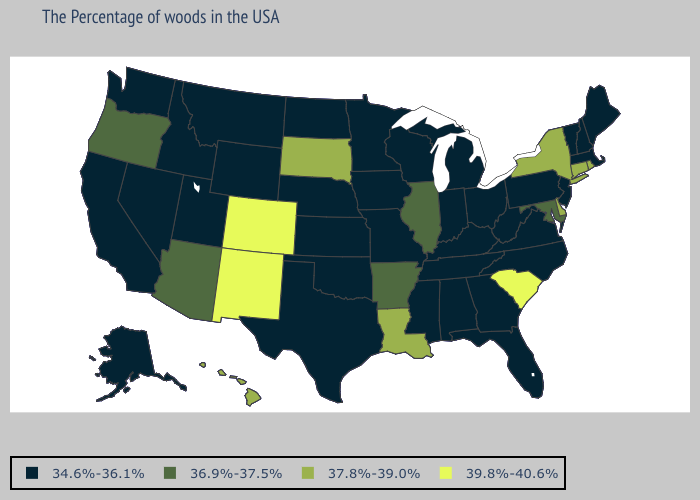Does Texas have a lower value than Delaware?
Write a very short answer. Yes. What is the lowest value in the Northeast?
Answer briefly. 34.6%-36.1%. What is the lowest value in states that border Illinois?
Concise answer only. 34.6%-36.1%. Which states have the lowest value in the USA?
Give a very brief answer. Maine, Massachusetts, New Hampshire, Vermont, New Jersey, Pennsylvania, Virginia, North Carolina, West Virginia, Ohio, Florida, Georgia, Michigan, Kentucky, Indiana, Alabama, Tennessee, Wisconsin, Mississippi, Missouri, Minnesota, Iowa, Kansas, Nebraska, Oklahoma, Texas, North Dakota, Wyoming, Utah, Montana, Idaho, Nevada, California, Washington, Alaska. What is the value of Texas?
Quick response, please. 34.6%-36.1%. What is the highest value in states that border Wyoming?
Give a very brief answer. 39.8%-40.6%. Name the states that have a value in the range 39.8%-40.6%?
Concise answer only. South Carolina, Colorado, New Mexico. What is the lowest value in the USA?
Concise answer only. 34.6%-36.1%. Does the map have missing data?
Short answer required. No. How many symbols are there in the legend?
Concise answer only. 4. Among the states that border Alabama , which have the lowest value?
Keep it brief. Florida, Georgia, Tennessee, Mississippi. Name the states that have a value in the range 37.8%-39.0%?
Be succinct. Rhode Island, Connecticut, New York, Delaware, Louisiana, South Dakota, Hawaii. Does West Virginia have the same value as Ohio?
Concise answer only. Yes. Does Alaska have the lowest value in the West?
Short answer required. Yes. 